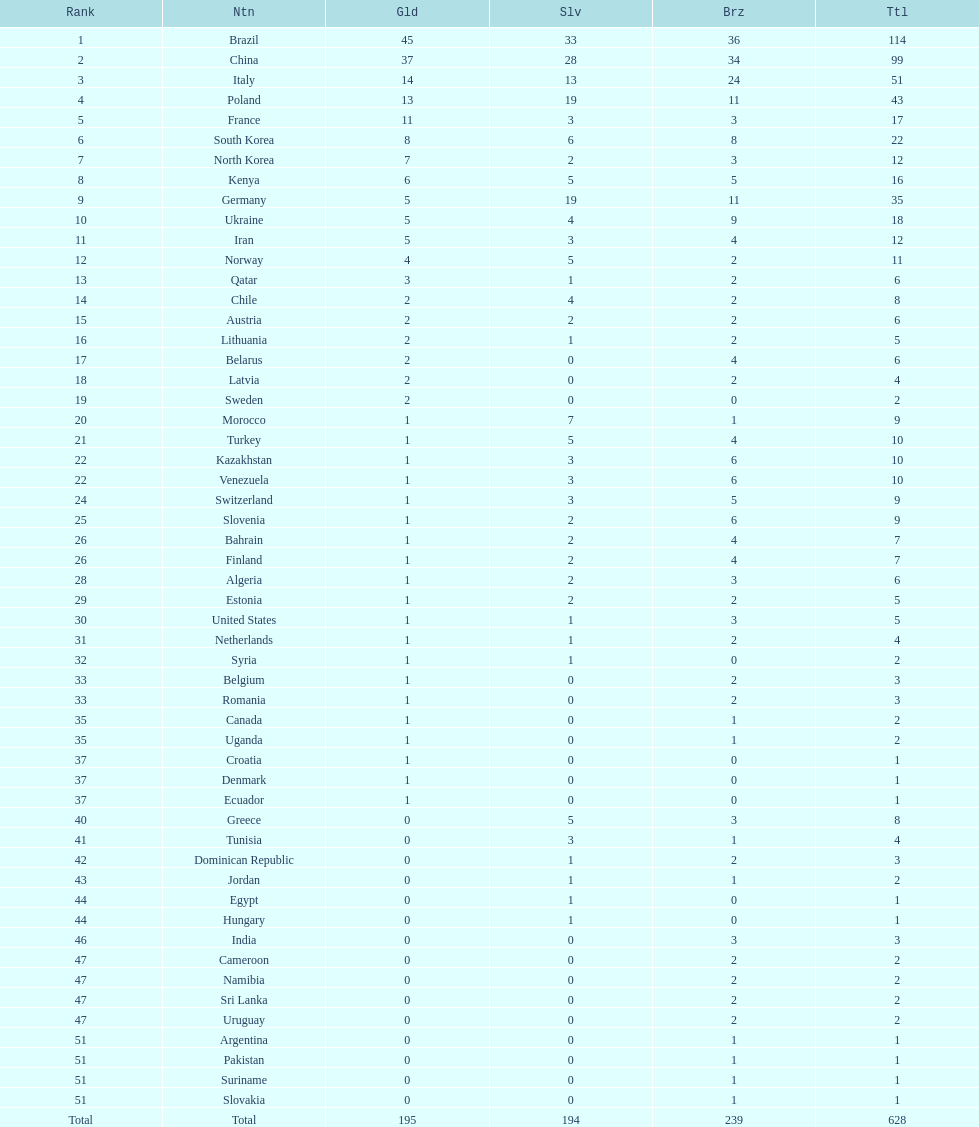How many medals have south korea, north korea, sweden, and brazil collectively won? 150. 